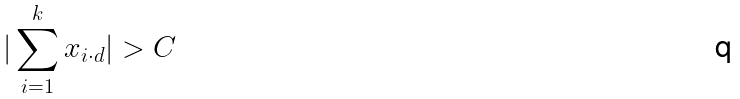Convert formula to latex. <formula><loc_0><loc_0><loc_500><loc_500>| \sum _ { i = 1 } ^ { k } x _ { i \cdot d } | > C</formula> 